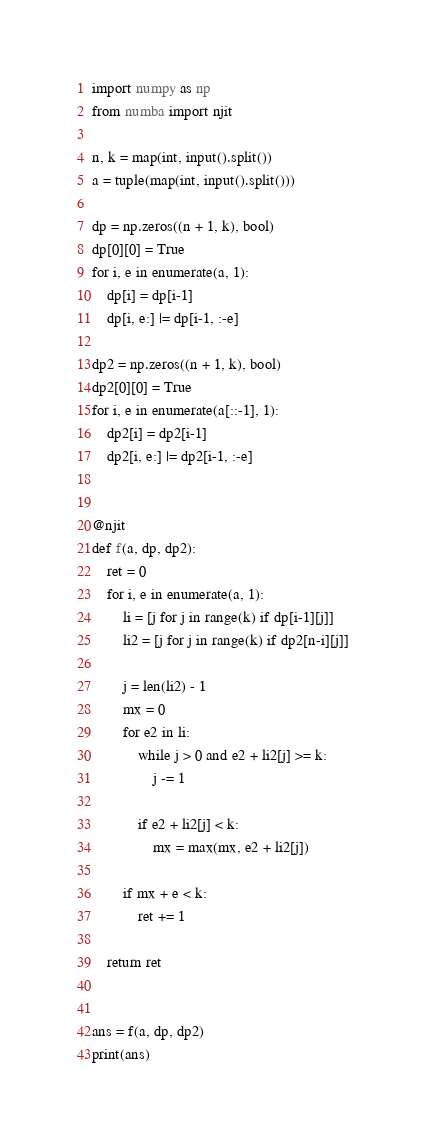Convert code to text. <code><loc_0><loc_0><loc_500><loc_500><_Python_>import numpy as np
from numba import njit

n, k = map(int, input().split())
a = tuple(map(int, input().split()))

dp = np.zeros((n + 1, k), bool)
dp[0][0] = True
for i, e in enumerate(a, 1):
    dp[i] = dp[i-1]
    dp[i, e:] |= dp[i-1, :-e]

dp2 = np.zeros((n + 1, k), bool)
dp2[0][0] = True
for i, e in enumerate(a[::-1], 1):
    dp2[i] = dp2[i-1]
    dp2[i, e:] |= dp2[i-1, :-e]


@njit
def f(a, dp, dp2):
    ret = 0
    for i, e in enumerate(a, 1):
        li = [j for j in range(k) if dp[i-1][j]]
        li2 = [j for j in range(k) if dp2[n-i][j]]

        j = len(li2) - 1
        mx = 0
        for e2 in li:
            while j > 0 and e2 + li2[j] >= k:
                j -= 1

            if e2 + li2[j] < k:
                mx = max(mx, e2 + li2[j])

        if mx + e < k:
            ret += 1

    return ret


ans = f(a, dp, dp2)
print(ans)
</code> 